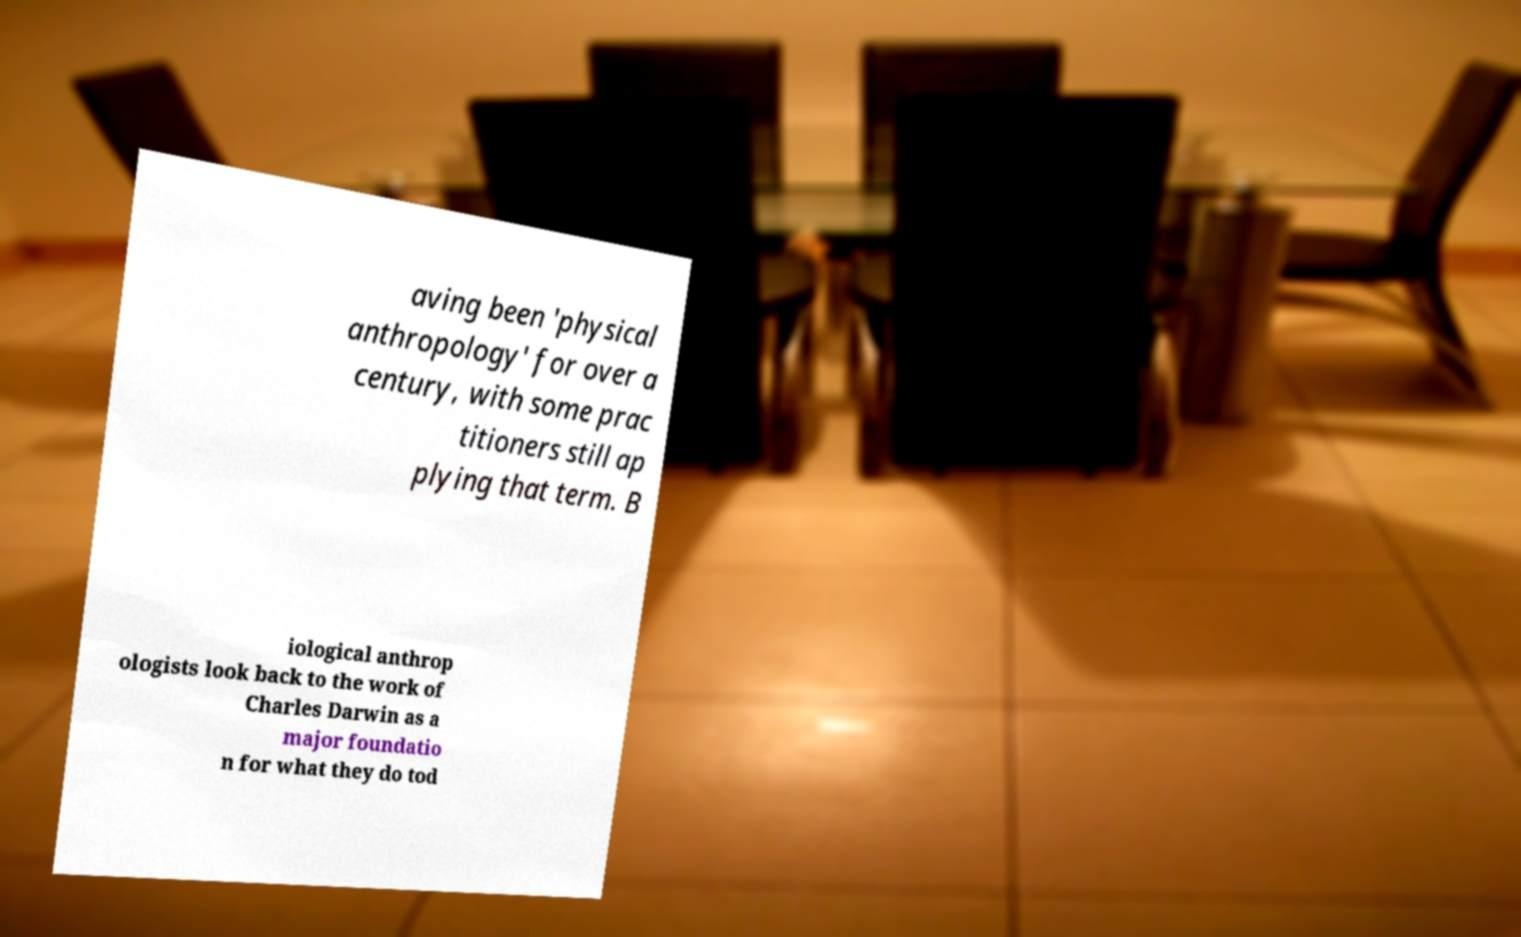Can you read and provide the text displayed in the image?This photo seems to have some interesting text. Can you extract and type it out for me? aving been 'physical anthropology' for over a century, with some prac titioners still ap plying that term. B iological anthrop ologists look back to the work of Charles Darwin as a major foundatio n for what they do tod 